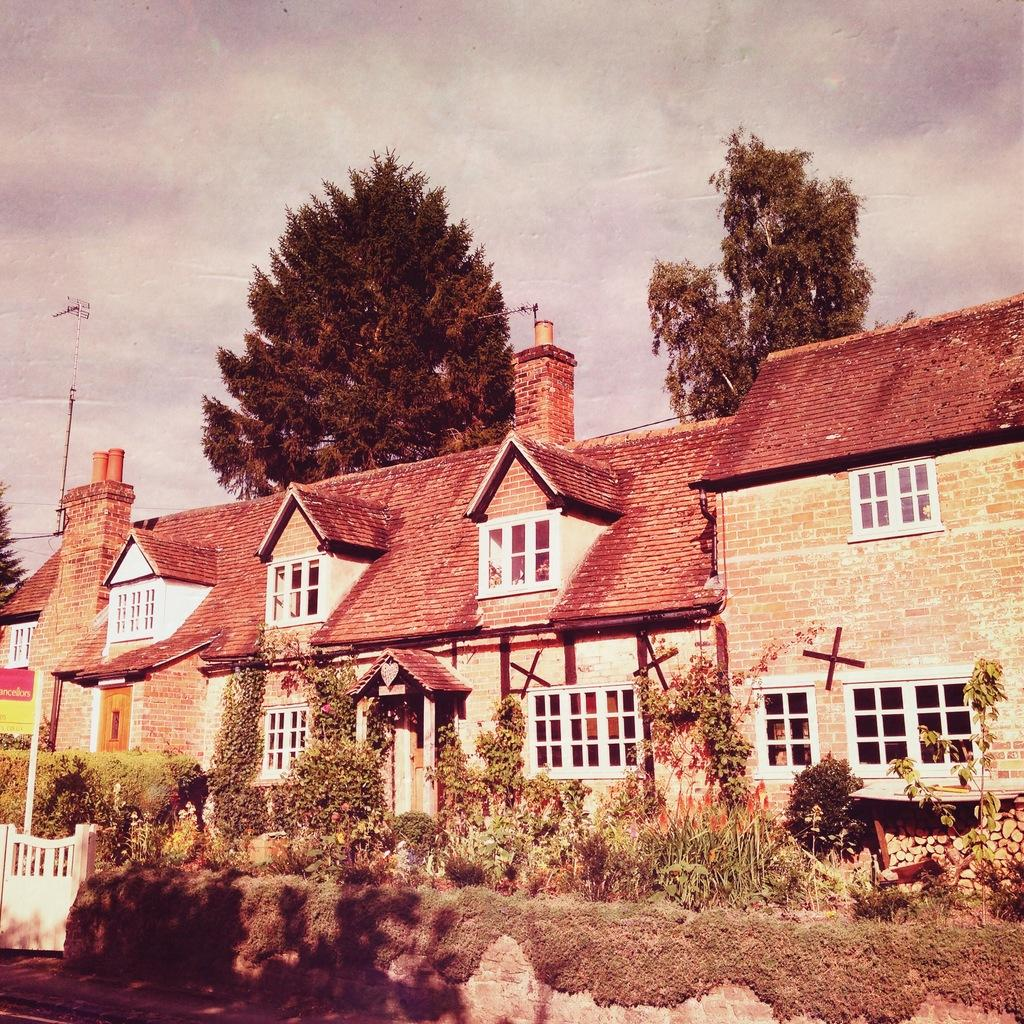What is located at the bottom of the image? There are plants and a gate at the bottom of the image. What can be seen in the middle of the image? There is a building and trees in the middle of the image. What is visible in the background of the image? The sky is visible in the background of the image. What type of gold amusement can be seen in the image? There is no gold amusement present in the image. What is the mouth of the building in the image? The building in the image does not have a mouth; it is a structure and not a living being. 